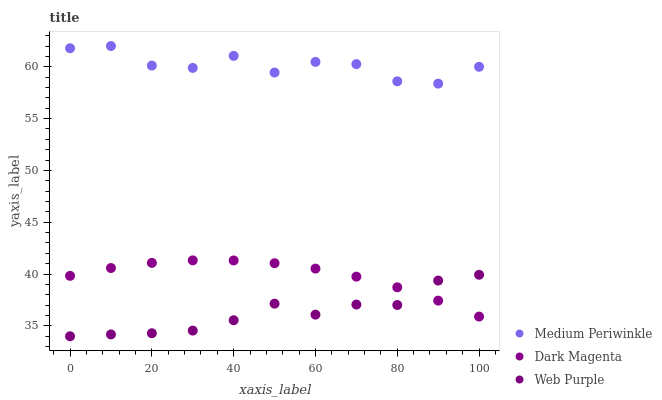Does Web Purple have the minimum area under the curve?
Answer yes or no. Yes. Does Medium Periwinkle have the maximum area under the curve?
Answer yes or no. Yes. Does Dark Magenta have the minimum area under the curve?
Answer yes or no. No. Does Dark Magenta have the maximum area under the curve?
Answer yes or no. No. Is Dark Magenta the smoothest?
Answer yes or no. Yes. Is Medium Periwinkle the roughest?
Answer yes or no. Yes. Is Medium Periwinkle the smoothest?
Answer yes or no. No. Is Dark Magenta the roughest?
Answer yes or no. No. Does Web Purple have the lowest value?
Answer yes or no. Yes. Does Dark Magenta have the lowest value?
Answer yes or no. No. Does Medium Periwinkle have the highest value?
Answer yes or no. Yes. Does Dark Magenta have the highest value?
Answer yes or no. No. Is Dark Magenta less than Medium Periwinkle?
Answer yes or no. Yes. Is Medium Periwinkle greater than Dark Magenta?
Answer yes or no. Yes. Does Dark Magenta intersect Web Purple?
Answer yes or no. Yes. Is Dark Magenta less than Web Purple?
Answer yes or no. No. Is Dark Magenta greater than Web Purple?
Answer yes or no. No. Does Dark Magenta intersect Medium Periwinkle?
Answer yes or no. No. 